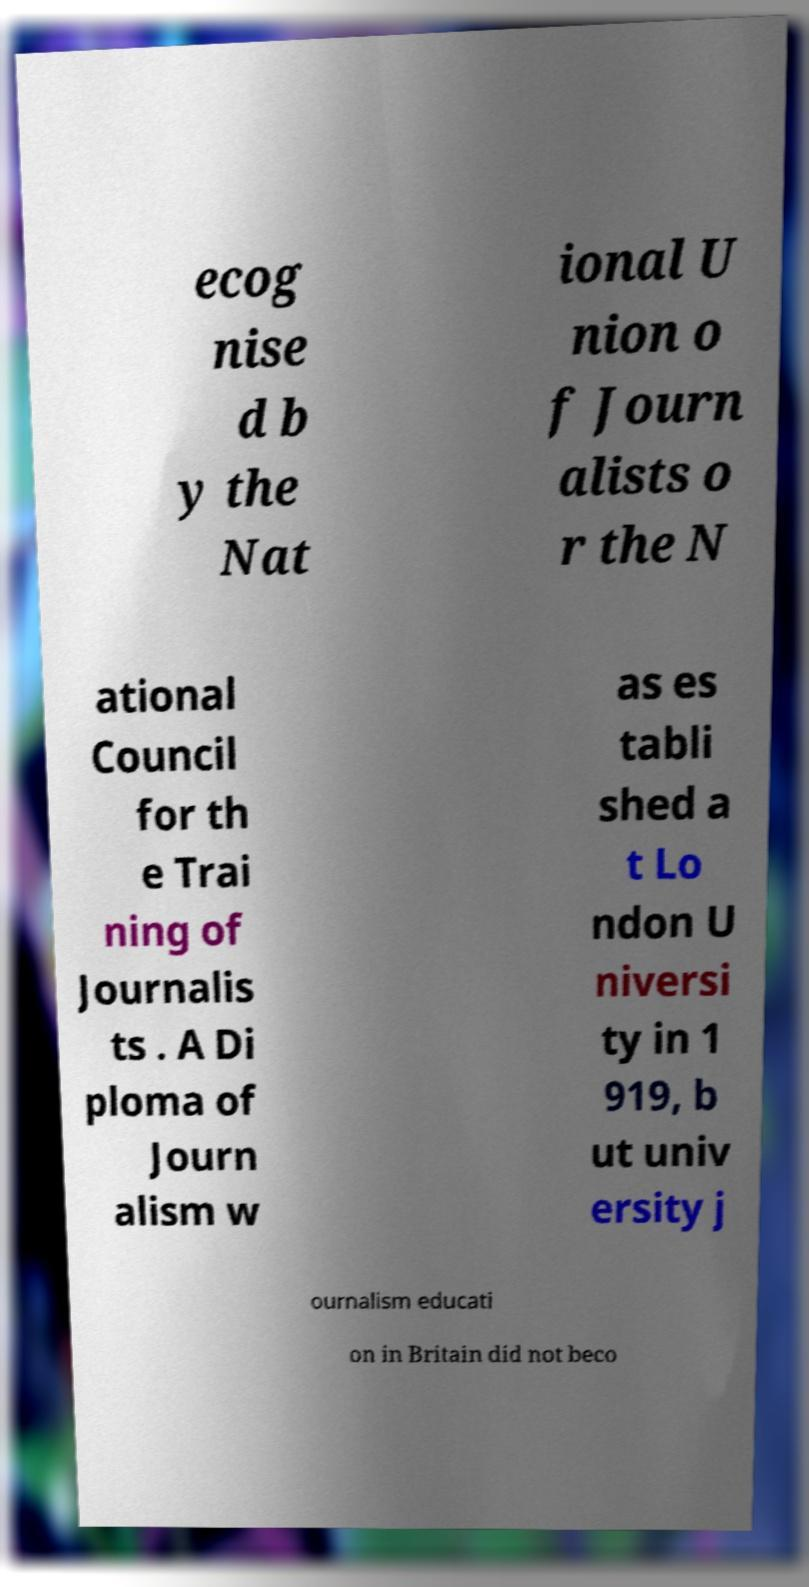Can you accurately transcribe the text from the provided image for me? ecog nise d b y the Nat ional U nion o f Journ alists o r the N ational Council for th e Trai ning of Journalis ts . A Di ploma of Journ alism w as es tabli shed a t Lo ndon U niversi ty in 1 919, b ut univ ersity j ournalism educati on in Britain did not beco 